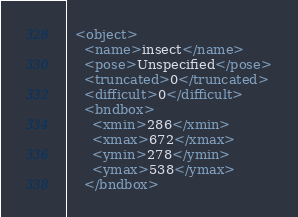<code> <loc_0><loc_0><loc_500><loc_500><_XML_>  <object>
    <name>insect</name>
    <pose>Unspecified</pose>
    <truncated>0</truncated>
    <difficult>0</difficult>
    <bndbox>
      <xmin>286</xmin>
      <xmax>672</xmax>
      <ymin>278</ymin>
      <ymax>538</ymax>
    </bndbox></code> 